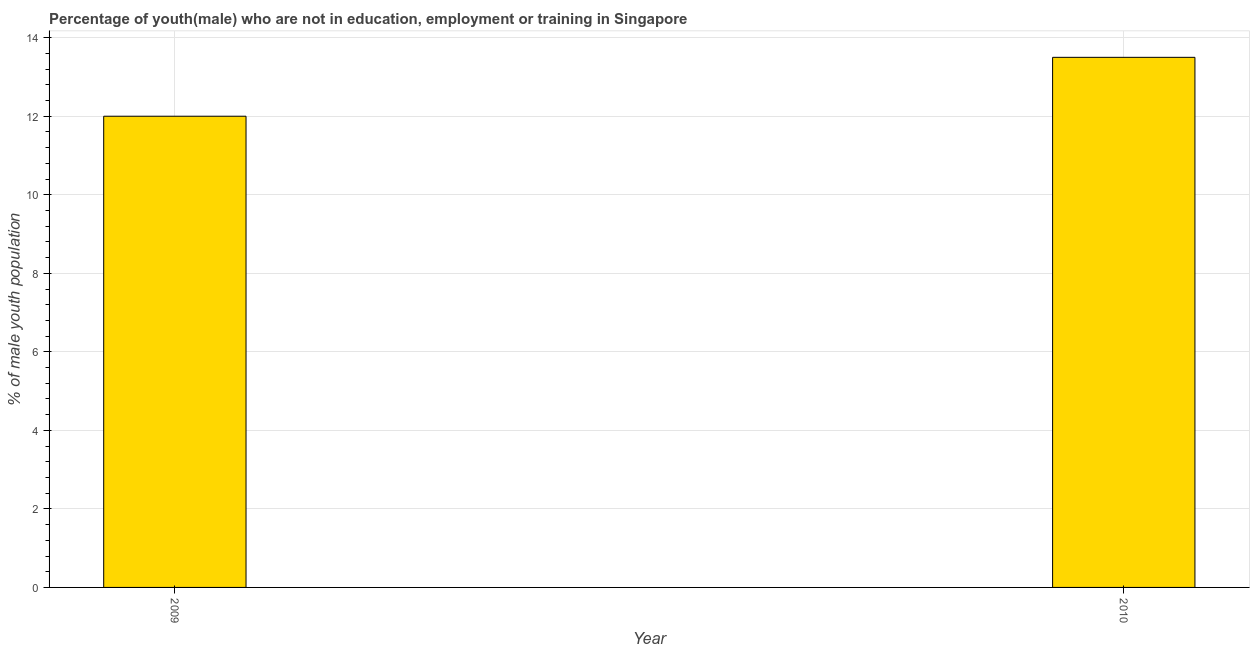What is the title of the graph?
Your answer should be very brief. Percentage of youth(male) who are not in education, employment or training in Singapore. What is the label or title of the X-axis?
Your answer should be very brief. Year. What is the label or title of the Y-axis?
Provide a short and direct response. % of male youth population. Across all years, what is the minimum unemployed male youth population?
Your answer should be compact. 12. In which year was the unemployed male youth population minimum?
Your answer should be very brief. 2009. What is the sum of the unemployed male youth population?
Offer a very short reply. 25.5. What is the average unemployed male youth population per year?
Offer a very short reply. 12.75. What is the median unemployed male youth population?
Your answer should be compact. 12.75. Do a majority of the years between 2009 and 2010 (inclusive) have unemployed male youth population greater than 2.8 %?
Provide a succinct answer. Yes. What is the ratio of the unemployed male youth population in 2009 to that in 2010?
Your response must be concise. 0.89. Is the unemployed male youth population in 2009 less than that in 2010?
Your answer should be compact. Yes. How many bars are there?
Offer a very short reply. 2. What is the % of male youth population in 2009?
Your response must be concise. 12. What is the % of male youth population of 2010?
Give a very brief answer. 13.5. What is the difference between the % of male youth population in 2009 and 2010?
Provide a succinct answer. -1.5. What is the ratio of the % of male youth population in 2009 to that in 2010?
Provide a short and direct response. 0.89. 